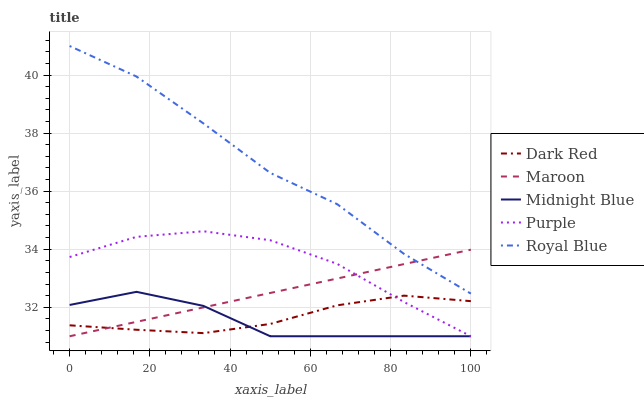Does Midnight Blue have the minimum area under the curve?
Answer yes or no. Yes. Does Royal Blue have the maximum area under the curve?
Answer yes or no. Yes. Does Dark Red have the minimum area under the curve?
Answer yes or no. No. Does Dark Red have the maximum area under the curve?
Answer yes or no. No. Is Maroon the smoothest?
Answer yes or no. Yes. Is Midnight Blue the roughest?
Answer yes or no. Yes. Is Dark Red the smoothest?
Answer yes or no. No. Is Dark Red the roughest?
Answer yes or no. No. Does Purple have the lowest value?
Answer yes or no. Yes. Does Dark Red have the lowest value?
Answer yes or no. No. Does Royal Blue have the highest value?
Answer yes or no. Yes. Does Midnight Blue have the highest value?
Answer yes or no. No. Is Purple less than Royal Blue?
Answer yes or no. Yes. Is Royal Blue greater than Midnight Blue?
Answer yes or no. Yes. Does Maroon intersect Dark Red?
Answer yes or no. Yes. Is Maroon less than Dark Red?
Answer yes or no. No. Is Maroon greater than Dark Red?
Answer yes or no. No. Does Purple intersect Royal Blue?
Answer yes or no. No. 